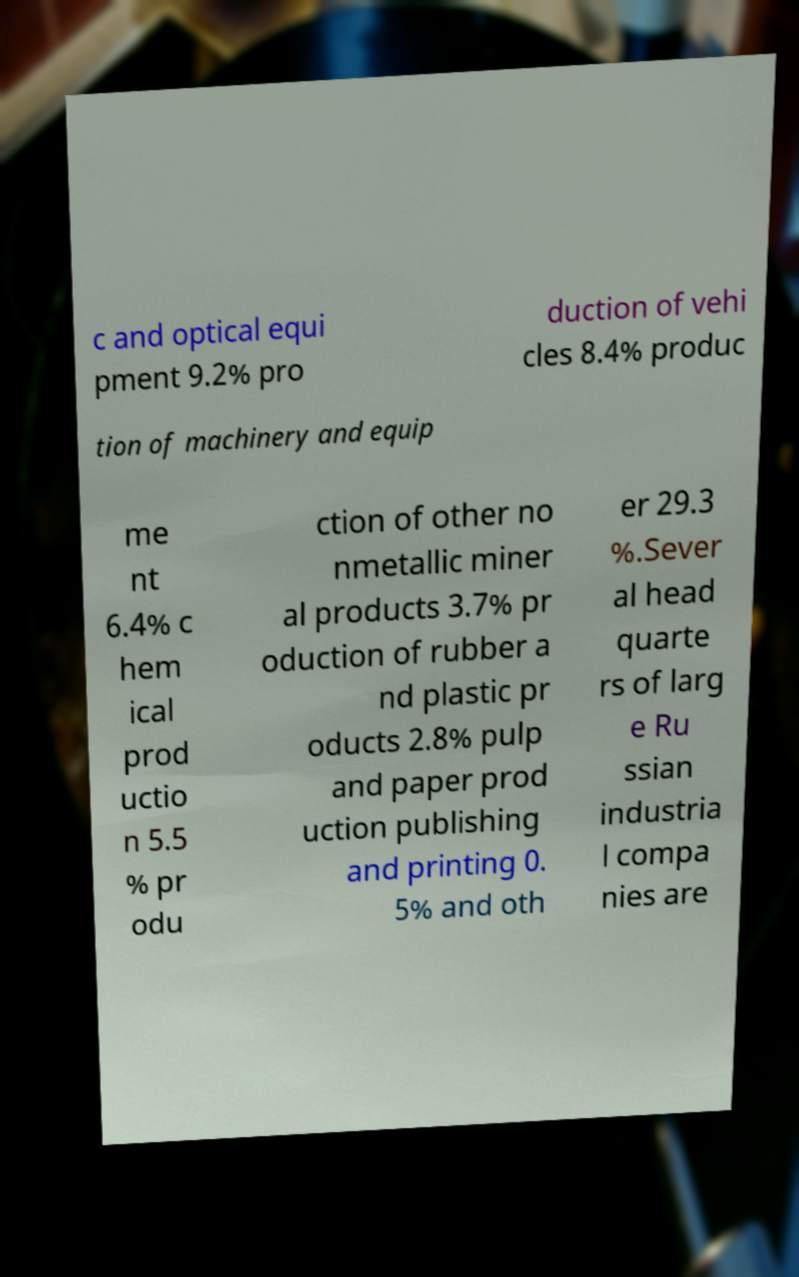Can you read and provide the text displayed in the image?This photo seems to have some interesting text. Can you extract and type it out for me? c and optical equi pment 9.2% pro duction of vehi cles 8.4% produc tion of machinery and equip me nt 6.4% c hem ical prod uctio n 5.5 % pr odu ction of other no nmetallic miner al products 3.7% pr oduction of rubber a nd plastic pr oducts 2.8% pulp and paper prod uction publishing and printing 0. 5% and oth er 29.3 %.Sever al head quarte rs of larg e Ru ssian industria l compa nies are 